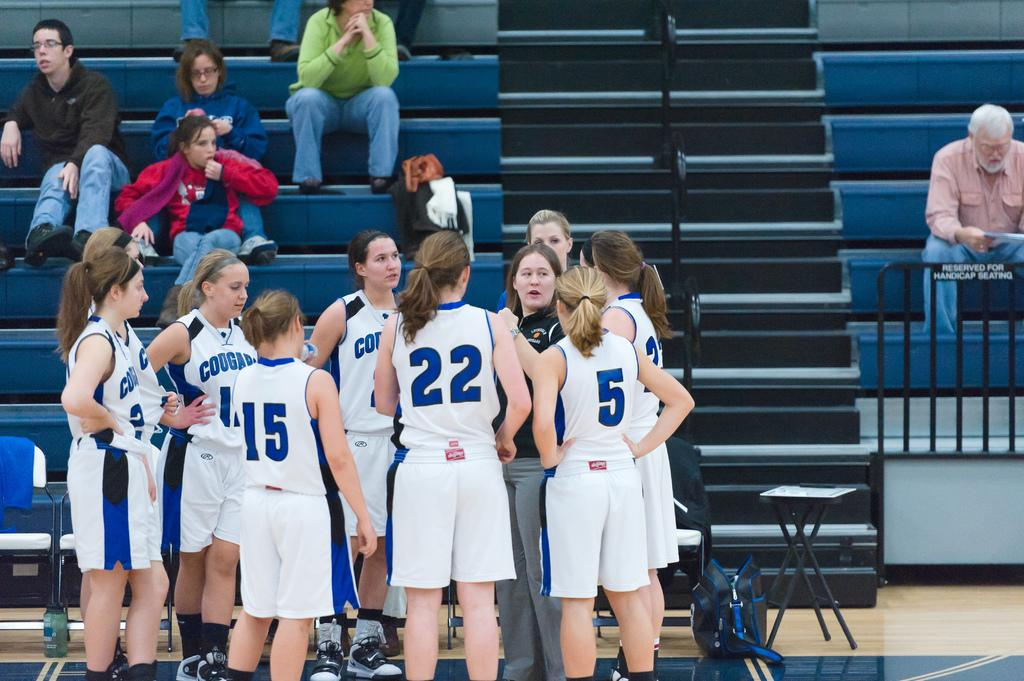<image>
Create a compact narrative representing the image presented. Player number 15 for the Cougars stands in a circle with other players 